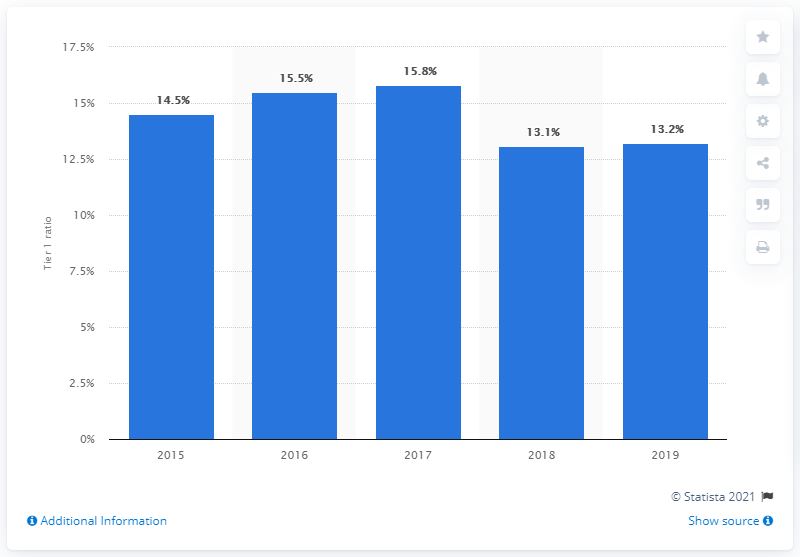What was the tier 1 ratio of Crdit Agricole in 2019? According to the bar chart, the Tier 1 ratio of Crédit Agricole in 2019 was precisely 13.2%. This ratio is a key indicator of a bank's financial health, reflecting its core equity capital compared to its total risk-weighted assets. 